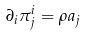<formula> <loc_0><loc_0><loc_500><loc_500>\partial _ { i } \pi ^ { i } _ { j } = \rho a _ { j }</formula> 